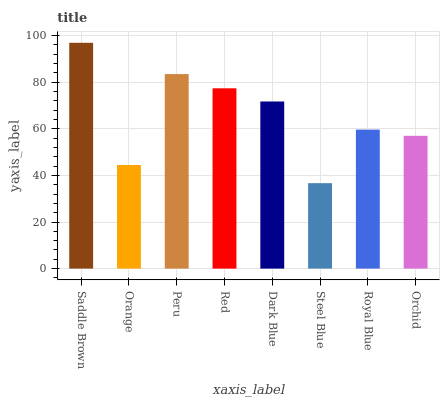Is Steel Blue the minimum?
Answer yes or no. Yes. Is Saddle Brown the maximum?
Answer yes or no. Yes. Is Orange the minimum?
Answer yes or no. No. Is Orange the maximum?
Answer yes or no. No. Is Saddle Brown greater than Orange?
Answer yes or no. Yes. Is Orange less than Saddle Brown?
Answer yes or no. Yes. Is Orange greater than Saddle Brown?
Answer yes or no. No. Is Saddle Brown less than Orange?
Answer yes or no. No. Is Dark Blue the high median?
Answer yes or no. Yes. Is Royal Blue the low median?
Answer yes or no. Yes. Is Peru the high median?
Answer yes or no. No. Is Orchid the low median?
Answer yes or no. No. 